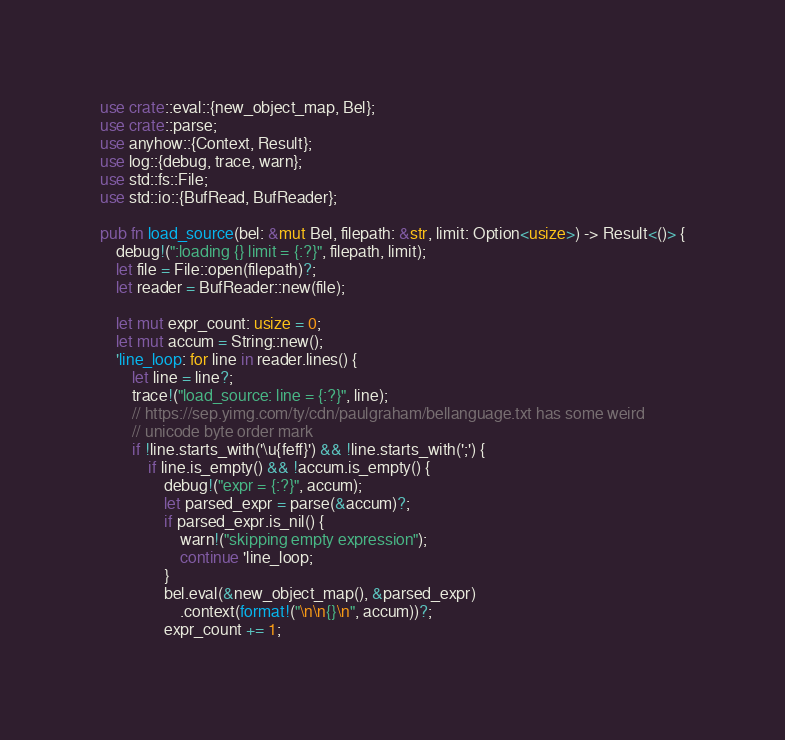Convert code to text. <code><loc_0><loc_0><loc_500><loc_500><_Rust_>use crate::eval::{new_object_map, Bel};
use crate::parse;
use anyhow::{Context, Result};
use log::{debug, trace, warn};
use std::fs::File;
use std::io::{BufRead, BufReader};

pub fn load_source(bel: &mut Bel, filepath: &str, limit: Option<usize>) -> Result<()> {
    debug!(":loading {} limit = {:?}", filepath, limit);
    let file = File::open(filepath)?;
    let reader = BufReader::new(file);

    let mut expr_count: usize = 0;
    let mut accum = String::new();
    'line_loop: for line in reader.lines() {
        let line = line?;
        trace!("load_source: line = {:?}", line);
        // https://sep.yimg.com/ty/cdn/paulgraham/bellanguage.txt has some weird
        // unicode byte order mark
        if !line.starts_with('\u{feff}') && !line.starts_with(';') {
            if line.is_empty() && !accum.is_empty() {
                debug!("expr = {:?}", accum);
                let parsed_expr = parse(&accum)?;
                if parsed_expr.is_nil() {
                    warn!("skipping empty expression");
                    continue 'line_loop;
                }
                bel.eval(&new_object_map(), &parsed_expr)
                    .context(format!("\n\n{}\n", accum))?;
                expr_count += 1;</code> 